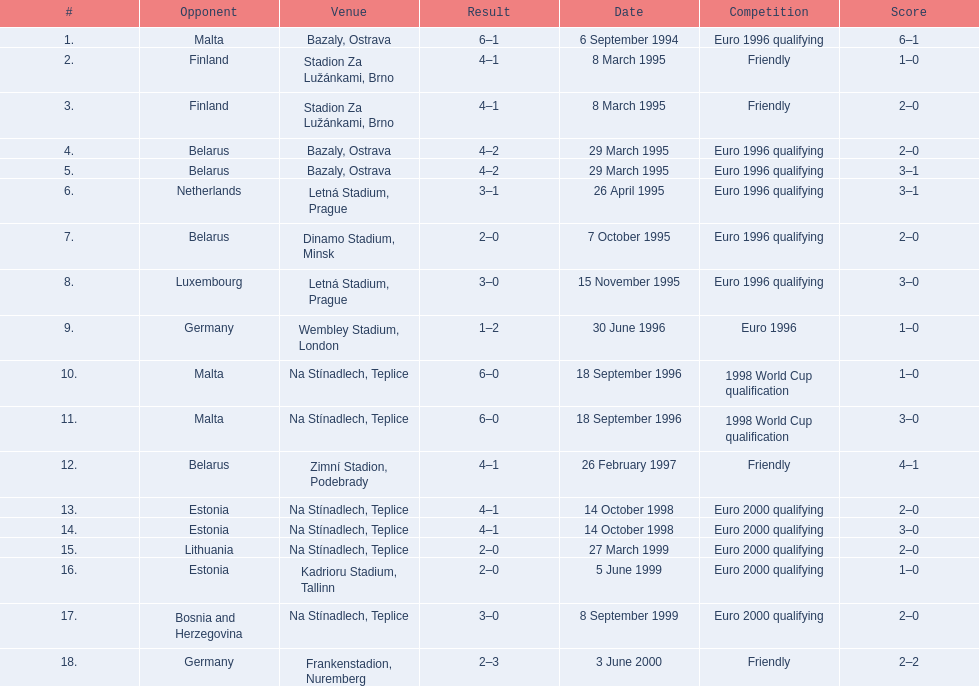How many total games took place in 1999? 3. Could you parse the entire table as a dict? {'header': ['#', 'Opponent', 'Venue', 'Result', 'Date', 'Competition', 'Score'], 'rows': [['1.', 'Malta', 'Bazaly, Ostrava', '6–1', '6 September 1994', 'Euro 1996 qualifying', '6–1'], ['2.', 'Finland', 'Stadion Za Lužánkami, Brno', '4–1', '8 March 1995', 'Friendly', '1–0'], ['3.', 'Finland', 'Stadion Za Lužánkami, Brno', '4–1', '8 March 1995', 'Friendly', '2–0'], ['4.', 'Belarus', 'Bazaly, Ostrava', '4–2', '29 March 1995', 'Euro 1996 qualifying', '2–0'], ['5.', 'Belarus', 'Bazaly, Ostrava', '4–2', '29 March 1995', 'Euro 1996 qualifying', '3–1'], ['6.', 'Netherlands', 'Letná Stadium, Prague', '3–1', '26 April 1995', 'Euro 1996 qualifying', '3–1'], ['7.', 'Belarus', 'Dinamo Stadium, Minsk', '2–0', '7 October 1995', 'Euro 1996 qualifying', '2–0'], ['8.', 'Luxembourg', 'Letná Stadium, Prague', '3–0', '15 November 1995', 'Euro 1996 qualifying', '3–0'], ['9.', 'Germany', 'Wembley Stadium, London', '1–2', '30 June 1996', 'Euro 1996', '1–0'], ['10.', 'Malta', 'Na Stínadlech, Teplice', '6–0', '18 September 1996', '1998 World Cup qualification', '1–0'], ['11.', 'Malta', 'Na Stínadlech, Teplice', '6–0', '18 September 1996', '1998 World Cup qualification', '3–0'], ['12.', 'Belarus', 'Zimní Stadion, Podebrady', '4–1', '26 February 1997', 'Friendly', '4–1'], ['13.', 'Estonia', 'Na Stínadlech, Teplice', '4–1', '14 October 1998', 'Euro 2000 qualifying', '2–0'], ['14.', 'Estonia', 'Na Stínadlech, Teplice', '4–1', '14 October 1998', 'Euro 2000 qualifying', '3–0'], ['15.', 'Lithuania', 'Na Stínadlech, Teplice', '2–0', '27 March 1999', 'Euro 2000 qualifying', '2–0'], ['16.', 'Estonia', 'Kadrioru Stadium, Tallinn', '2–0', '5 June 1999', 'Euro 2000 qualifying', '1–0'], ['17.', 'Bosnia and Herzegovina', 'Na Stínadlech, Teplice', '3–0', '8 September 1999', 'Euro 2000 qualifying', '2–0'], ['18.', 'Germany', 'Frankenstadion, Nuremberg', '2–3', '3 June 2000', 'Friendly', '2–2']]} 